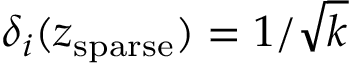<formula> <loc_0><loc_0><loc_500><loc_500>\delta _ { i } ( z _ { s p a r s e } ) = { 1 } / { \sqrt { k } }</formula> 